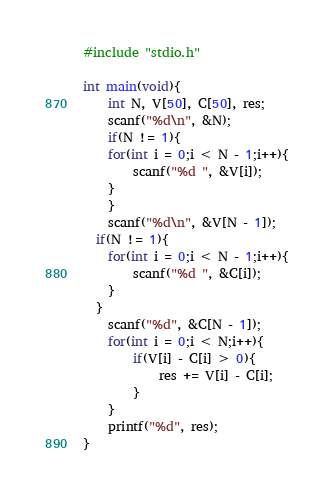Convert code to text. <code><loc_0><loc_0><loc_500><loc_500><_C_>#include "stdio.h"
 
int main(void){
	int N, V[50], C[50], res;
	scanf("%d\n", &N);
	if(N != 1){
	for(int i = 0;i < N - 1;i++){
		scanf("%d ", &V[i]);
	}
    }
	scanf("%d\n", &V[N - 1]);
  if(N != 1){
	for(int i = 0;i < N - 1;i++){
		scanf("%d ", &C[i]);
	}
  }
	scanf("%d", &C[N - 1]);
	for(int i = 0;i < N;i++){
		if(V[i] - C[i] > 0){
        	res += V[i] - C[i];
        }
	}
	printf("%d", res);
}</code> 